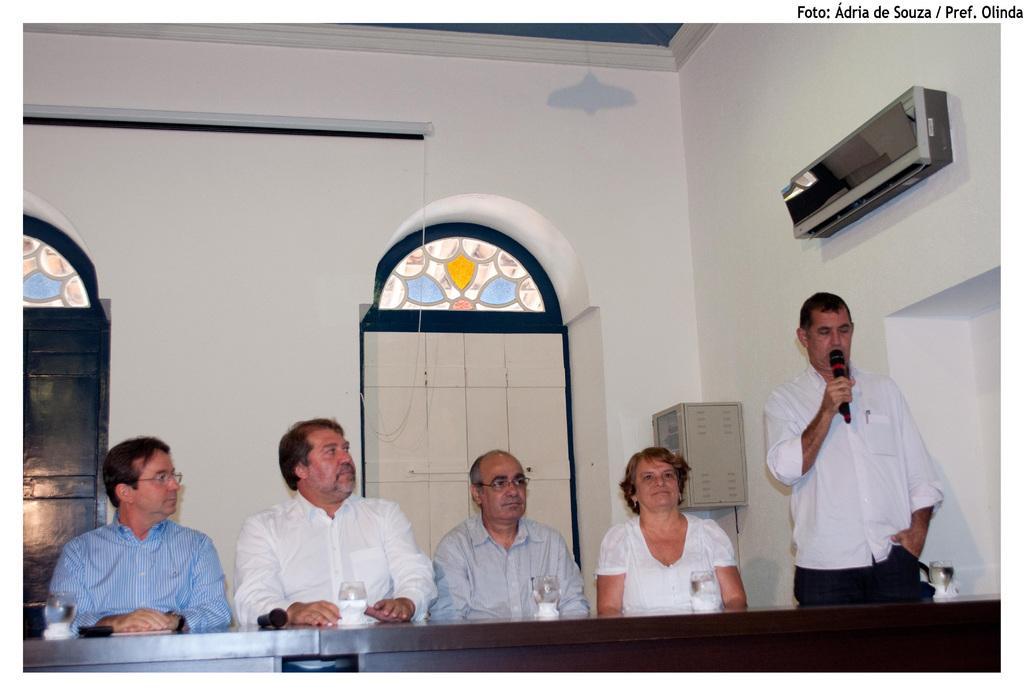How would you summarize this image in a sentence or two? In this image there are four persons sitting on the chair. In front of them there is a table and on top of the table there is a glass, mobile phone and a mike. At the right side of the image there is a person standing by holding the mike. At the back side there is a wall. At the right side of the image there is an AC attached to the wall. 